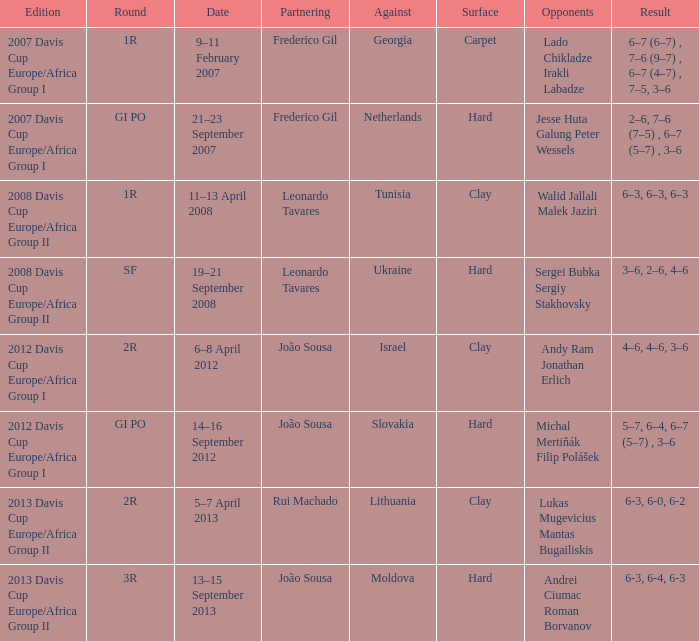What Edition had a Result of 6-3, 6-0, 6-2? 2013 Davis Cup Europe/Africa Group II. 